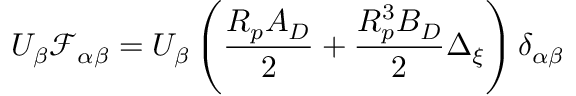<formula> <loc_0><loc_0><loc_500><loc_500>U _ { \beta } \mathcal { F } _ { \alpha \beta } = U _ { \beta } \left ( \frac { R _ { p } A _ { D } } { 2 } + \frac { R _ { p } ^ { 3 } B _ { D } } { 2 } \Delta _ { \xi } \right ) \delta _ { \alpha \beta }</formula> 